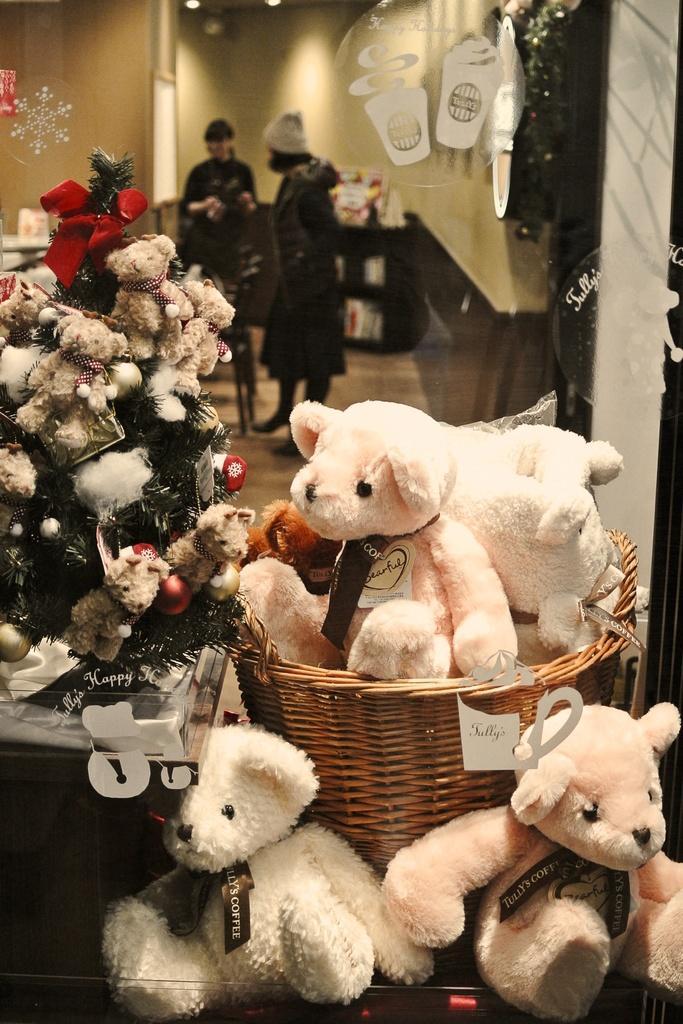Describe this image in one or two sentences. In this image we can see a group of dolls, a basket and a tree decorated with some toys and a ribbon. On the backside we can see a wall and some people standing on the floor. 